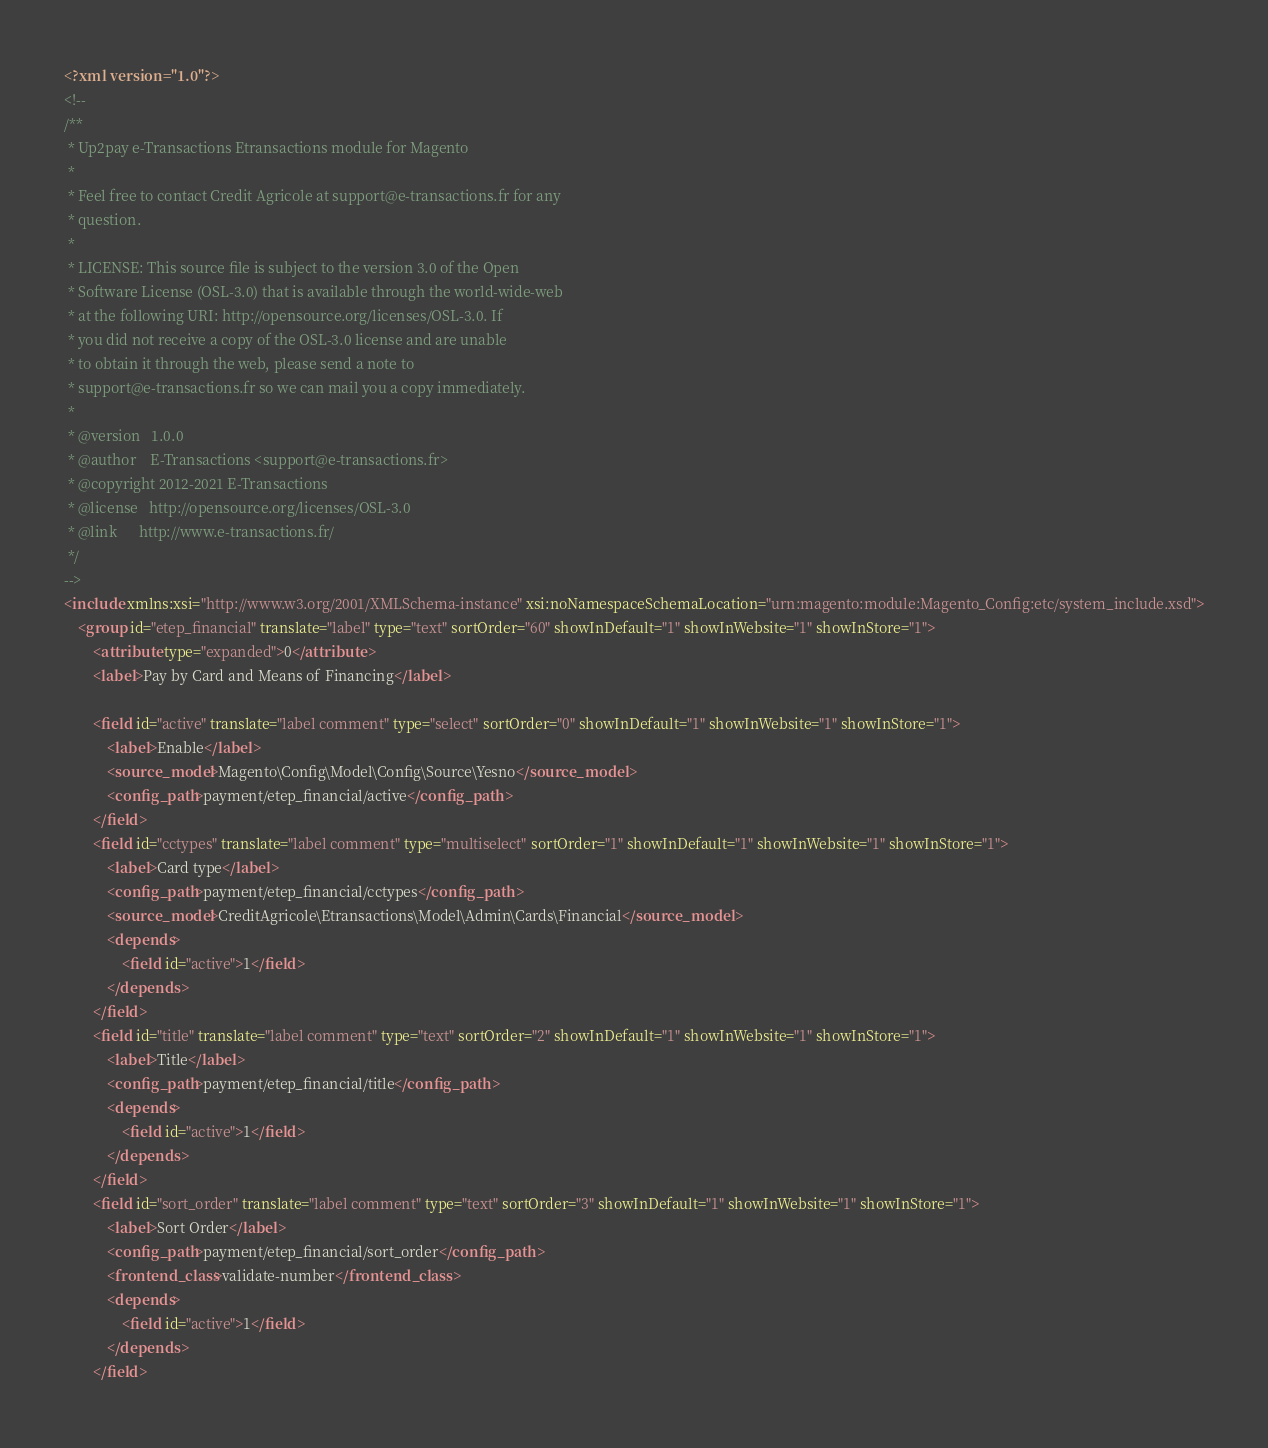Convert code to text. <code><loc_0><loc_0><loc_500><loc_500><_XML_><?xml version="1.0"?>
<!--
/**
 * Up2pay e-Transactions Etransactions module for Magento
 *
 * Feel free to contact Credit Agricole at support@e-transactions.fr for any
 * question.
 *
 * LICENSE: This source file is subject to the version 3.0 of the Open
 * Software License (OSL-3.0) that is available through the world-wide-web
 * at the following URI: http://opensource.org/licenses/OSL-3.0. If
 * you did not receive a copy of the OSL-3.0 license and are unable
 * to obtain it through the web, please send a note to
 * support@e-transactions.fr so we can mail you a copy immediately.
 *
 * @version   1.0.0
 * @author    E-Transactions <support@e-transactions.fr>
 * @copyright 2012-2021 E-Transactions
 * @license   http://opensource.org/licenses/OSL-3.0
 * @link      http://www.e-transactions.fr/
 */
-->
<include xmlns:xsi="http://www.w3.org/2001/XMLSchema-instance" xsi:noNamespaceSchemaLocation="urn:magento:module:Magento_Config:etc/system_include.xsd">
    <group id="etep_financial" translate="label" type="text" sortOrder="60" showInDefault="1" showInWebsite="1" showInStore="1">
        <attribute type="expanded">0</attribute>
        <label>Pay by Card and Means of Financing</label>

        <field id="active" translate="label comment" type="select" sortOrder="0" showInDefault="1" showInWebsite="1" showInStore="1">
            <label>Enable</label>
            <source_model>Magento\Config\Model\Config\Source\Yesno</source_model>
            <config_path>payment/etep_financial/active</config_path>
        </field>
        <field id="cctypes" translate="label comment" type="multiselect" sortOrder="1" showInDefault="1" showInWebsite="1" showInStore="1">
            <label>Card type</label>
            <config_path>payment/etep_financial/cctypes</config_path>
            <source_model>CreditAgricole\Etransactions\Model\Admin\Cards\Financial</source_model>
            <depends>
                <field id="active">1</field>
            </depends>
        </field>
        <field id="title" translate="label comment" type="text" sortOrder="2" showInDefault="1" showInWebsite="1" showInStore="1">
        	<label>Title</label>
            <config_path>payment/etep_financial/title</config_path>
        	<depends>
                <field id="active">1</field>
            </depends>
        </field>
        <field id="sort_order" translate="label comment" type="text" sortOrder="3" showInDefault="1" showInWebsite="1" showInStore="1">
        	<label>Sort Order</label>
        	<config_path>payment/etep_financial/sort_order</config_path>
        	<frontend_class>validate-number</frontend_class>
        	<depends>
                <field id="active">1</field>
            </depends>
        </field>
</code> 